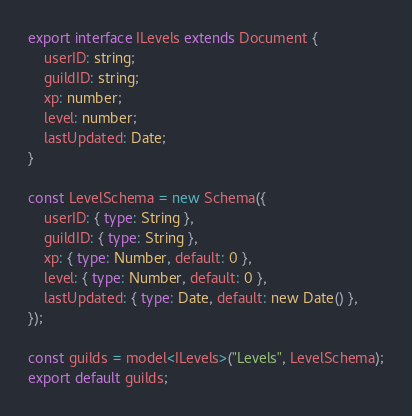<code> <loc_0><loc_0><loc_500><loc_500><_TypeScript_>export interface ILevels extends Document {
    userID: string;
    guildID: string;
    xp: number;
    level: number;
    lastUpdated: Date;
}

const LevelSchema = new Schema({
    userID: { type: String },
    guildID: { type: String },
    xp: { type: Number, default: 0 },
    level: { type: Number, default: 0 },
    lastUpdated: { type: Date, default: new Date() },
});

const guilds = model<ILevels>("Levels", LevelSchema);
export default guilds;</code> 